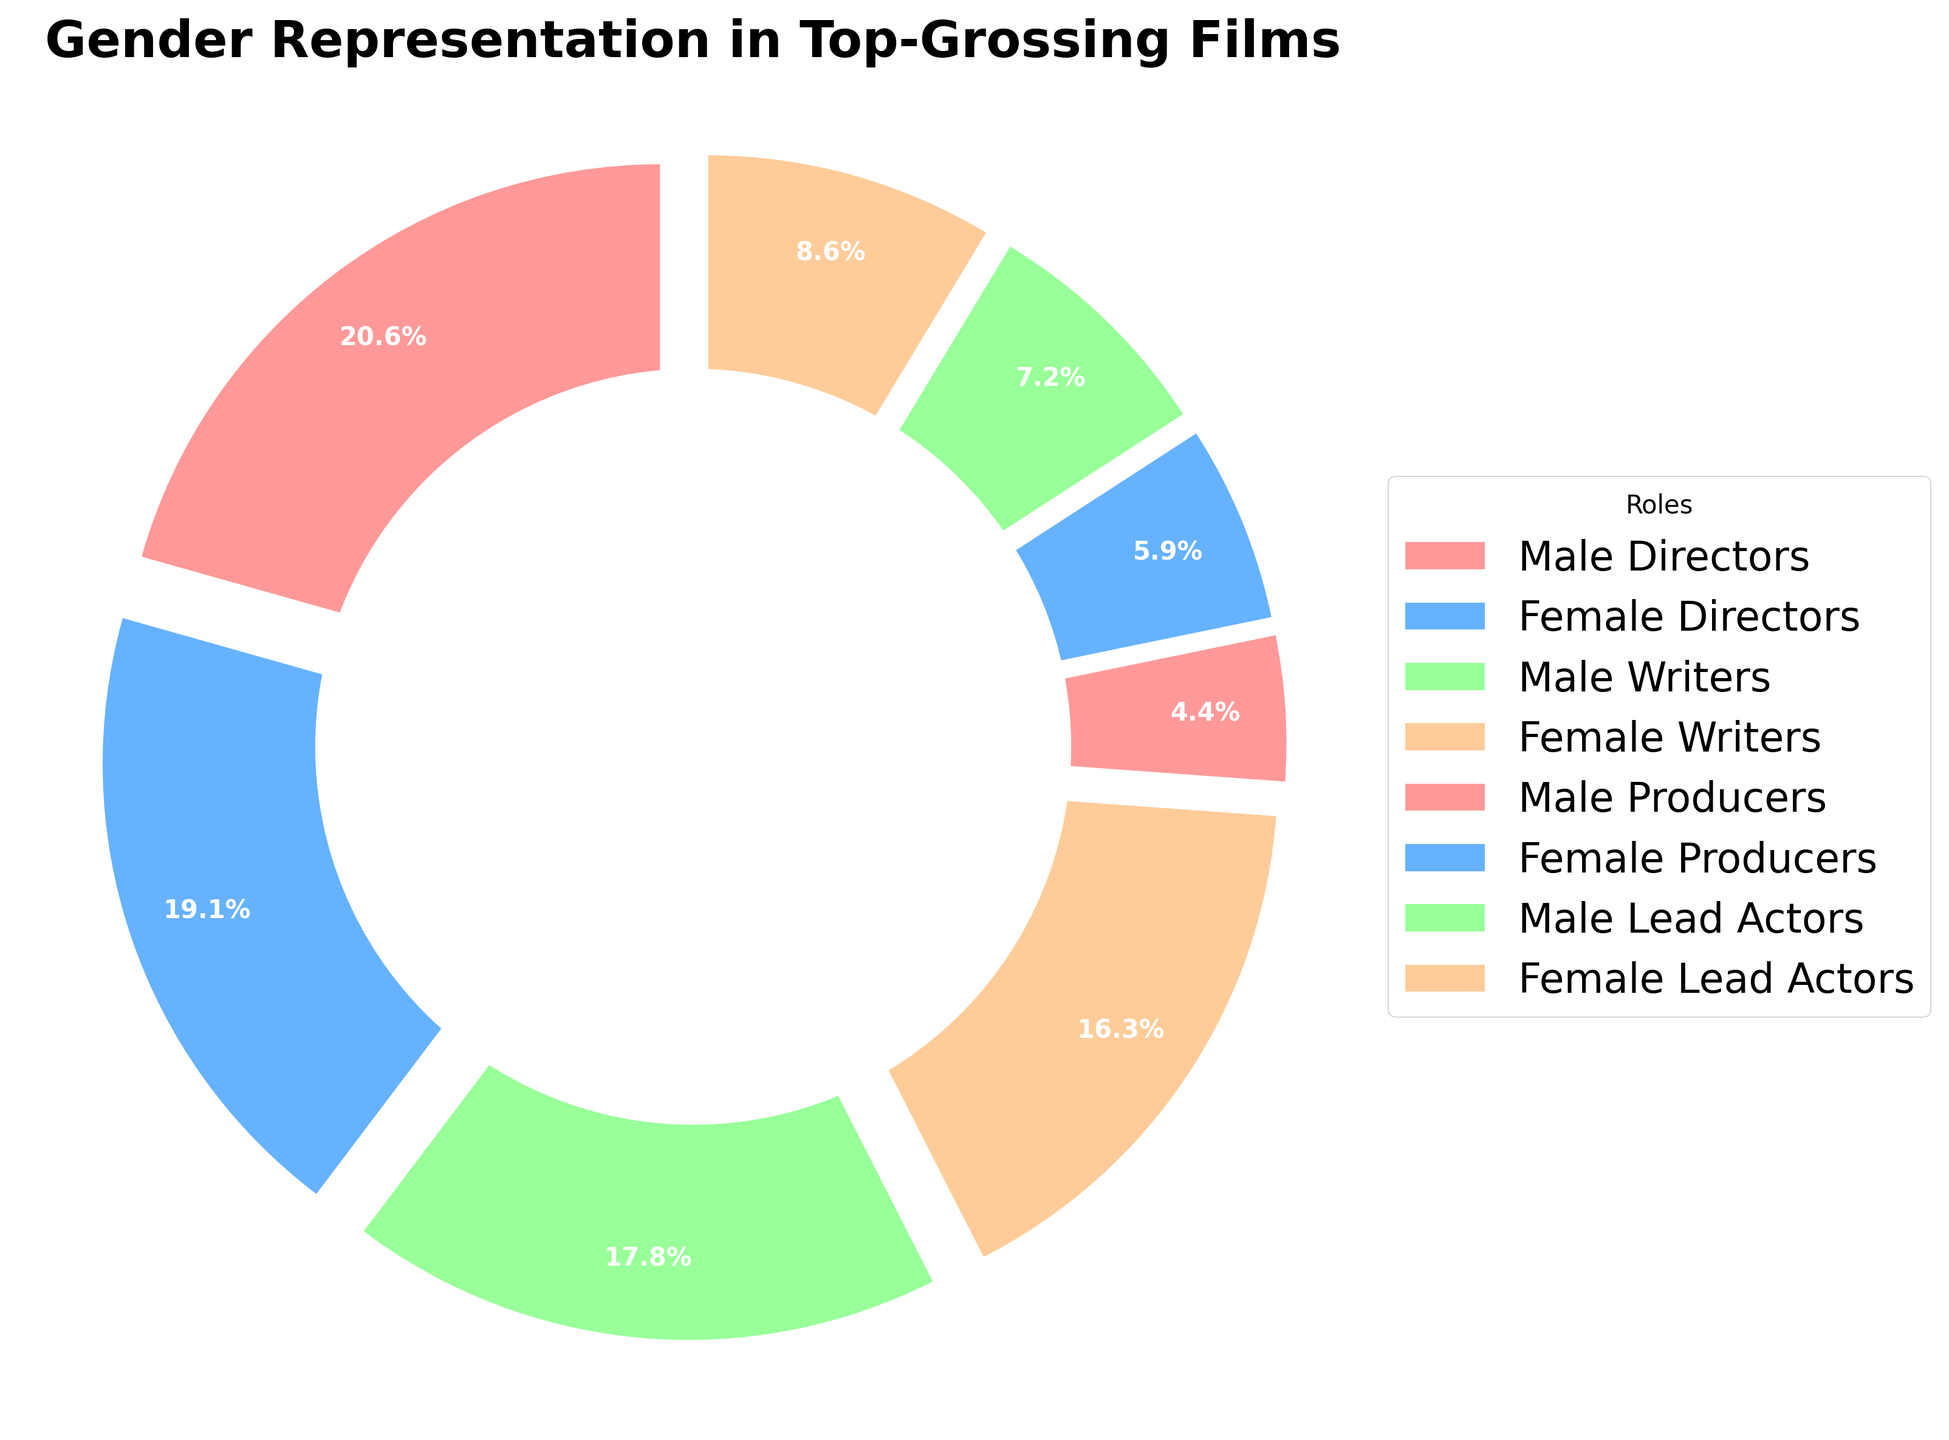Which role has the highest percentage of female representation? First, look for the role section in the legend associated with female representation. Then, compare the percentages of female directors, writers, producers, and lead actors. Female producers have the highest percentage at 28.8%.
Answer: Female producers What is the difference between male and female lead actors in percentage? Find the percentages for male and female lead actors, which are 65.4% and 34.6% respectively. Subtract the female percentage from the male percentage: 65.4% - 34.6% = 30.8%.
Answer: 30.8% Which role shows the smallest gender gap in representation? Compare the differences between male and female representations in each role: directors (82.5% - 17.5% = 65%), writers (76.3% - 23.7% = 52.6%), producers (71.2% - 28.8% = 42.4%), and lead actors (65.4% - 34.6% = 30.8%). The smallest difference is for lead actors at 30.8%.
Answer: Lead actor What is the total percentage of males in all four roles combined? Sum the percentages for males in all roles: 82.5% (directors) + 76.3% (writers) + 71.2% (producers) + 65.4% (lead actors) = 295.4%.
Answer: 295.4% Compare the percentage of female writers to male directors. Which is higher? Look at the percentages for female writers (23.7%) and male directors (82.5%). Clearly, 82.5% is higher than 23.7%.
Answer: Male directors What percentage of the roles are held by women in total? Sum up the percentages for females in all roles: 17.5% (directors) + 23.7% (writers) + 28.8% (producers) + 34.6% (lead actors) = 104.6%.
Answer: 104.6% Which color represents female directors in the pie chart? Locate the sector with 17.5% in the pie chart, representing female directors. The corresponding color in the legend will be pink.
Answer: Pink 